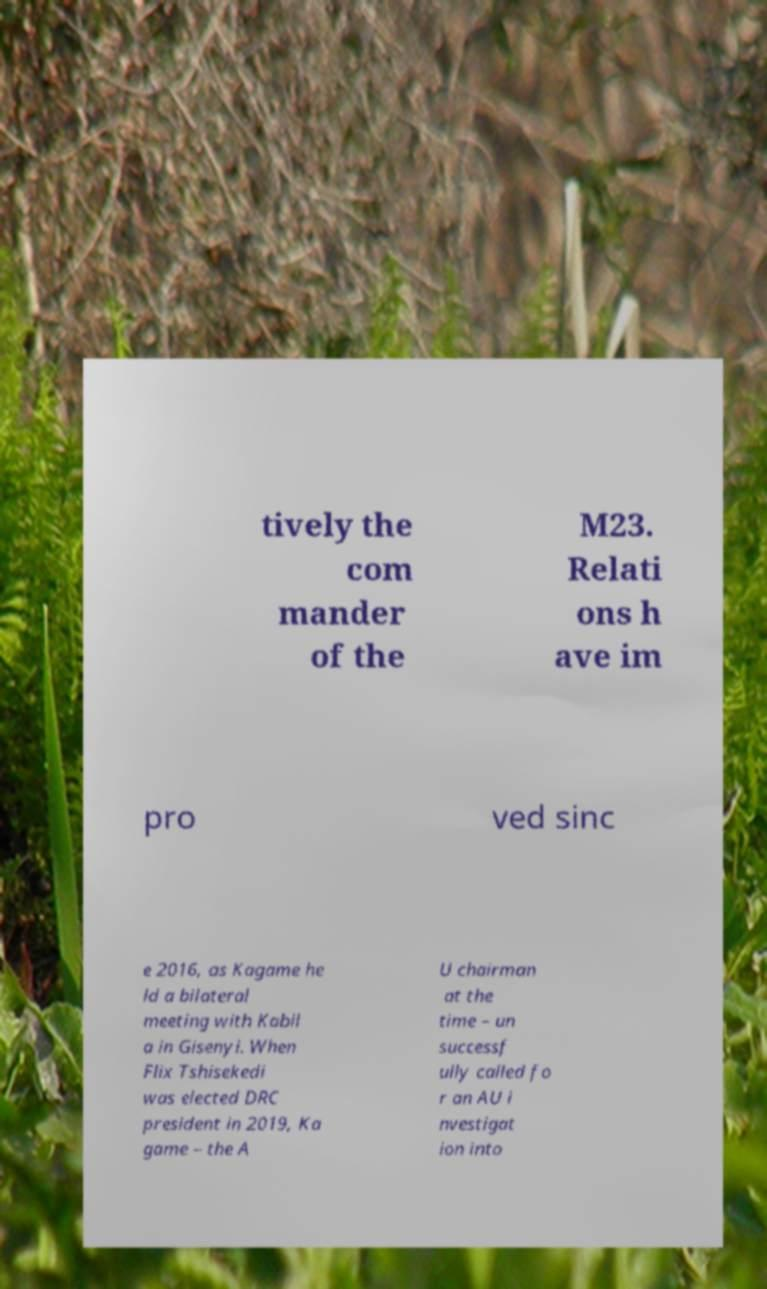Could you assist in decoding the text presented in this image and type it out clearly? tively the com mander of the M23. Relati ons h ave im pro ved sinc e 2016, as Kagame he ld a bilateral meeting with Kabil a in Gisenyi. When Flix Tshisekedi was elected DRC president in 2019, Ka game – the A U chairman at the time – un successf ully called fo r an AU i nvestigat ion into 